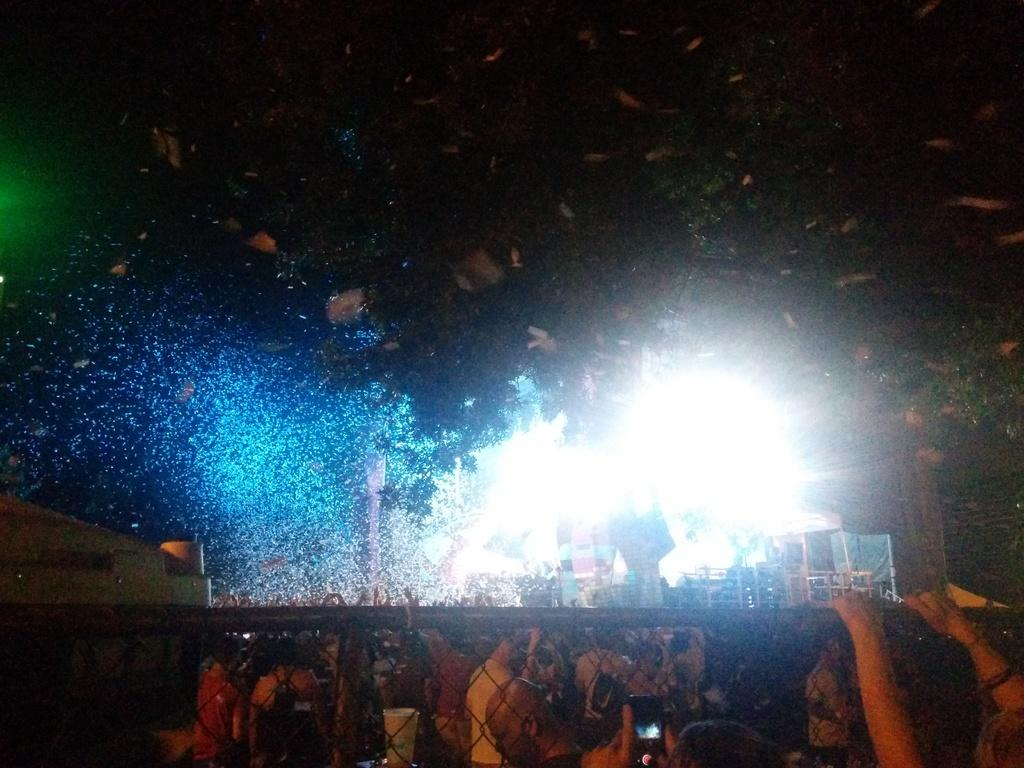Who or what can be seen in the image? There are people in the image. What structure is present in the image? There is a fence in the image. What can be seen in the distance in the image? There are lights and sheds in the background of the image. How many snails can be seen crawling on the fence in the image? There are no snails visible on the fence in the image. What type of apple is being held by one of the people in the image? There is no apple present in the image. 